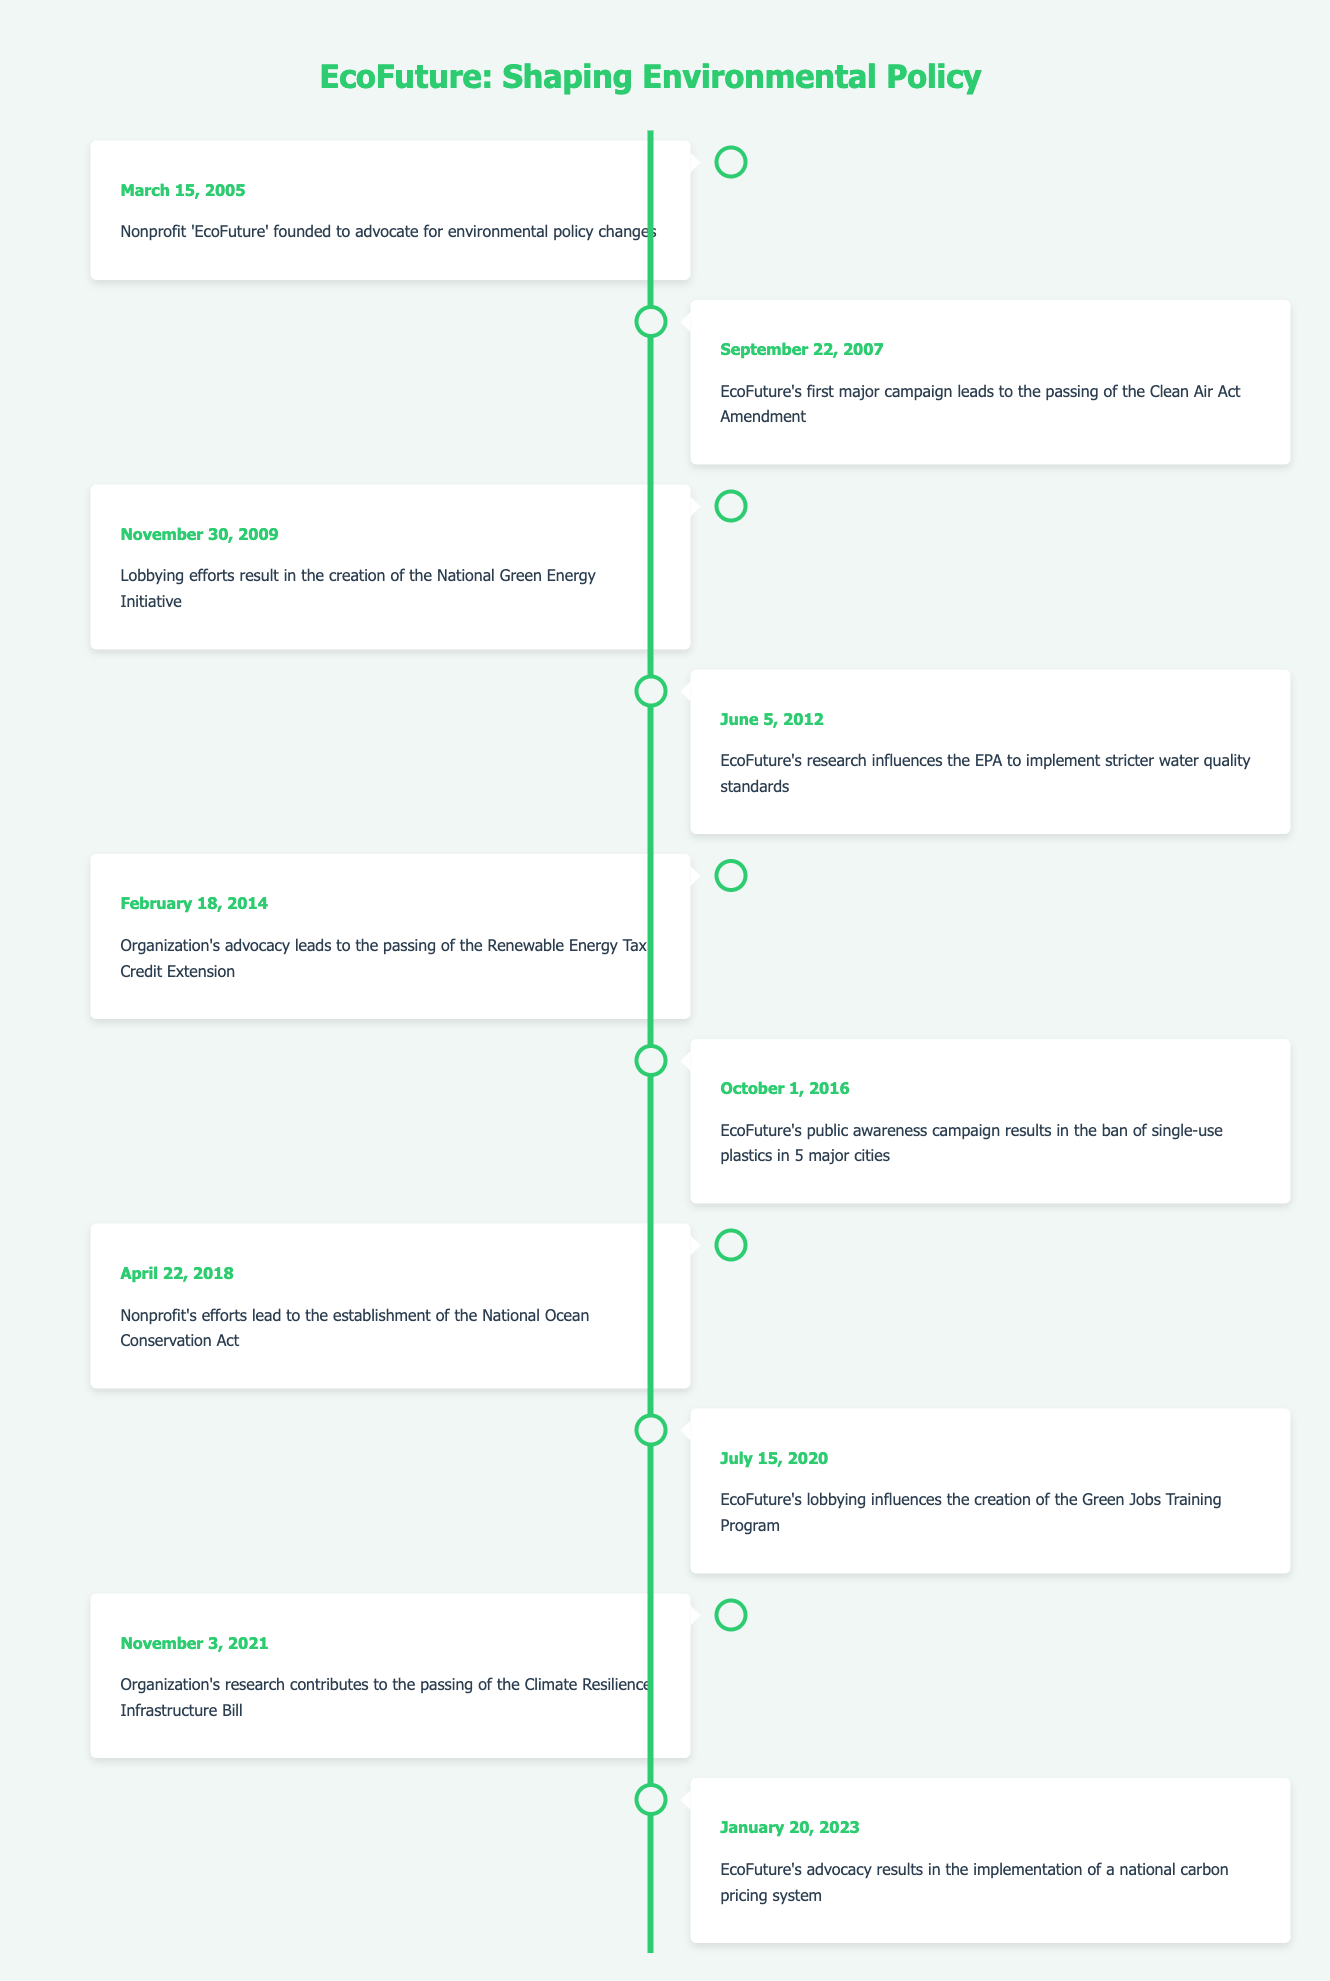What date was EcoFuture founded? EcoFuture was founded on March 15, 2005, as indicated in the timeline.
Answer: March 15, 2005 How many major policy changes occurred before 2015? Reviewing the timeline, events up to 2014 are: Clean Air Act Amendment (2007), National Green Energy Initiative (2009), stricter water quality standards (2012), and Renewable Energy Tax Credit Extension (2014). There are 4 events before 2015.
Answer: 4 Did EcoFuture influence the implementation of a national carbon pricing system? Yes, the timeline explicitly states that on January 20, 2023, EcoFuture's advocacy resulted in the national carbon pricing system implementation.
Answer: Yes What is the difference between the years of the establishment of EcoFuture and the establishment of the National Ocean Conservation Act? EcoFuture was founded in 2005, and the National Ocean Conservation Act was established in 2018. The difference is 2018 - 2005 = 13 years.
Answer: 13 years Which event was the first major policy change after EcoFuture was founded? The first event after the founding of EcoFuture is the passing of the Clean Air Act Amendment on September 22, 2007.
Answer: Clean Air Act Amendment How many events are listed after 2020? There are 2 events after 2020: the Climate Resilience Infrastructure Bill (2021) and the national carbon pricing system (2023).
Answer: 2 Was the banning of single-use plastics a result of EcoFuture’s advocacy? Yes, the timeline notes that on October 1, 2016, EcoFuture's public awareness campaign resulted in the ban of single-use plastics.
Answer: Yes Which event took place closest to the midpoint of EcoFuture's timeline? The midpoint can be estimated between the first event (2005) and the last event (2023), placing it around 2014. The event that occurs closest is the Renewable Energy Tax Credit Extension on February 18, 2014.
Answer: Renewable Energy Tax Credit Extension What percentage of events led to the creation of new legislation? There are 10 events total, and 6 of them resulted in new legislation. Therefore, the percentage is (6/10) * 100 = 60%.
Answer: 60% 